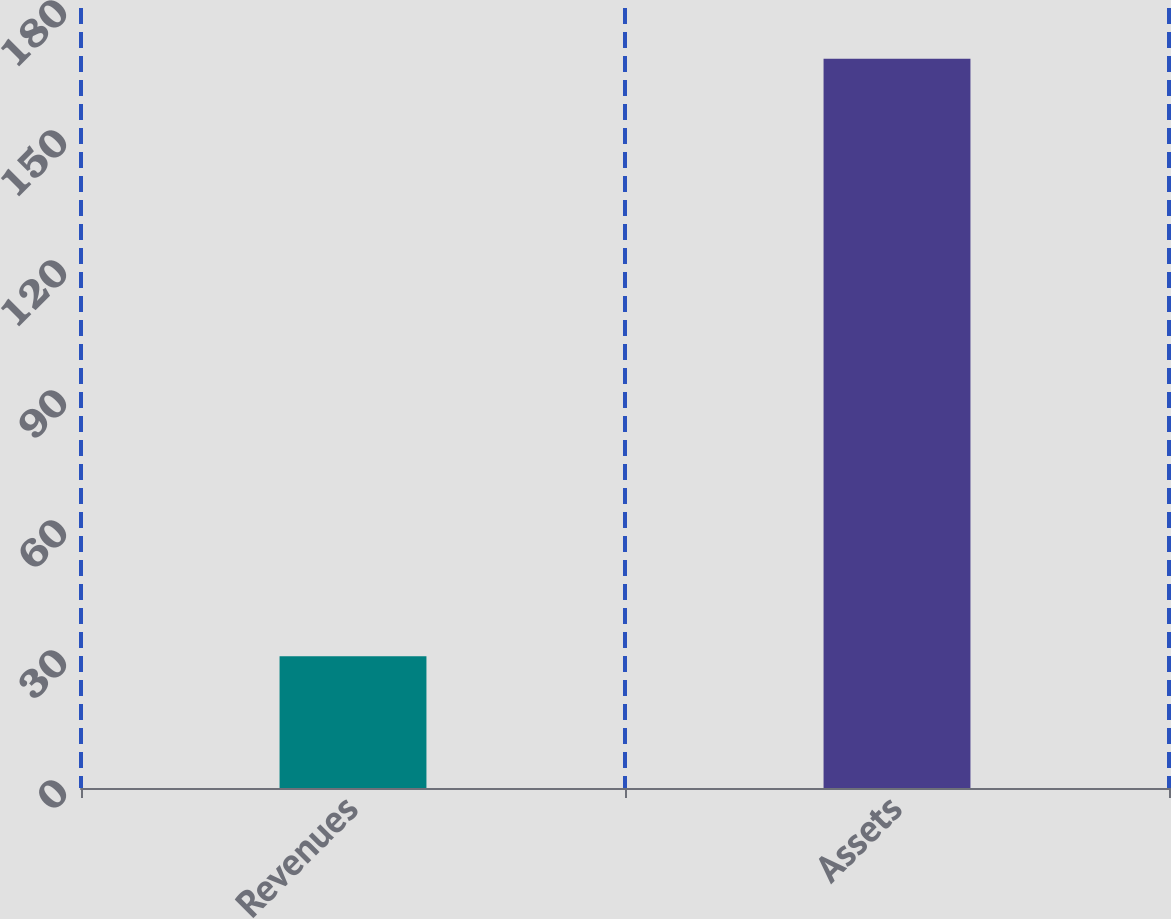<chart> <loc_0><loc_0><loc_500><loc_500><bar_chart><fcel>Revenues<fcel>Assets<nl><fcel>30.4<fcel>168.3<nl></chart> 